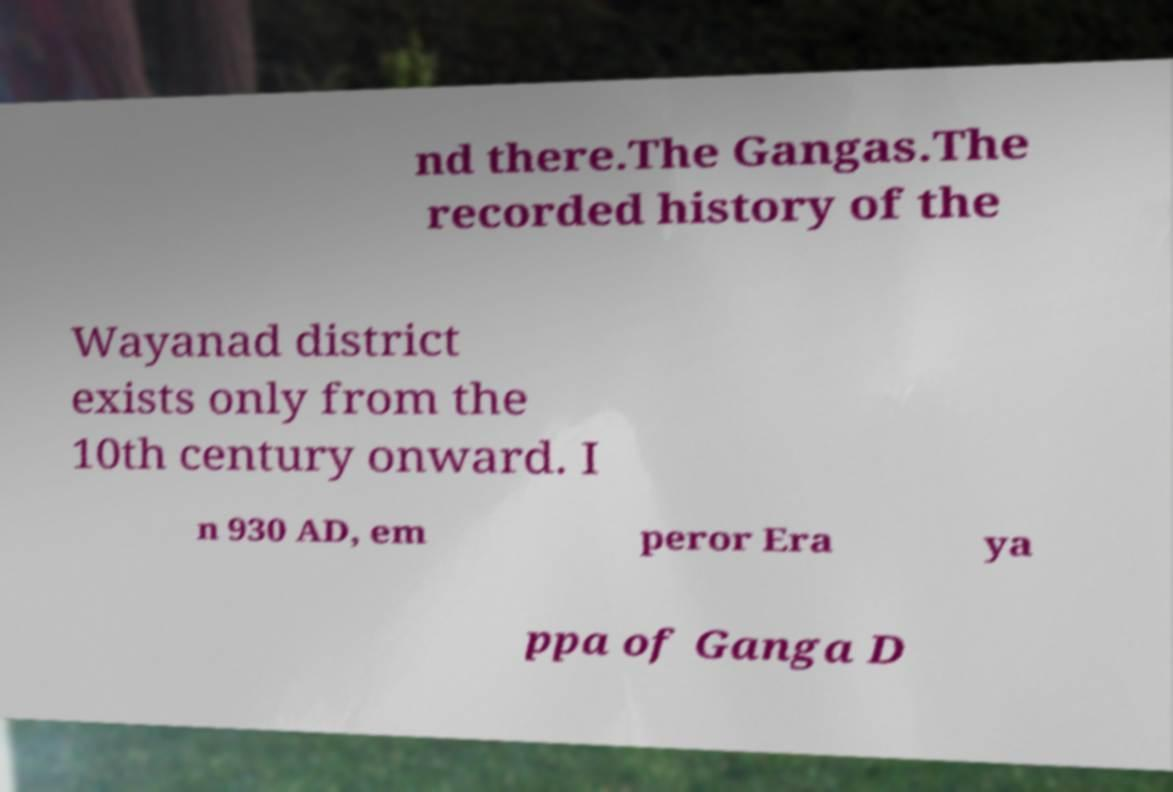Could you extract and type out the text from this image? nd there.The Gangas.The recorded history of the Wayanad district exists only from the 10th century onward. I n 930 AD, em peror Era ya ppa of Ganga D 